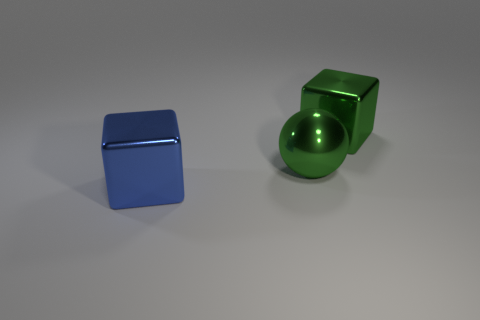Add 2 big blue matte balls. How many objects exist? 5 Subtract all green cubes. How many cubes are left? 1 Subtract all spheres. How many objects are left? 2 Subtract all green cubes. Subtract all red cylinders. How many cubes are left? 1 Subtract all blue cylinders. How many brown spheres are left? 0 Subtract all green metallic balls. Subtract all big green cubes. How many objects are left? 1 Add 3 large green balls. How many large green balls are left? 4 Add 3 green objects. How many green objects exist? 5 Subtract 0 brown spheres. How many objects are left? 3 